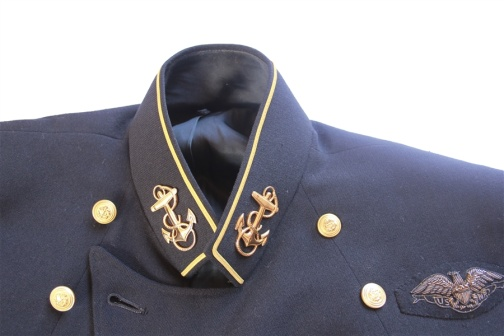Imagine this jacket was worn by a person of significant historical importance. Who could that be? Imagining this jacket was worn by a person of significant historical importance, it could belong to an esteemed naval admiral or a decorated officer responsible for leading critical maritime operations during a pivotal moment in history, such as WWII. This person could have been instrumental in orchestrating naval strategies that changed the course of wartime efforts, thus earning a uniform embellished with fine details denoting authority and high ranks. What kind of materials and craftsmanship would have been used to create such a jacket? To create such a jacket, tailors would have employed high-quality, durable materials like wool for the base fabric, ensuring it could withstand harsh conditions while providing a professional appearance. The gold accents and buttons would likely be made from gold-plated brass or similar metals, chosen for their luster and ability to hold up over time. Craftsmanship involved meticulous stitching, especially for the detailed embroidered insignias and piping. Each element would be carefully measured and placed to maintain uniformity and balance, reflecting the discipline of the wearer’s role. What kind of story can you weave around this jacket involving a fictional adventure? Picture this jacket on a daring naval officer, Captain Alexander Drake, who commanded one of the most formidable ships of the 1940s. Captain Drake was known for his sharp tactical mind and his ability to lead men through impossible odds. During one perilous mission, his ship, the HMS Vanguard, was tasked with intercepting an enemy convoy carrying crucial war supplies across treacherous waters. Against a backdrop of raging seas and encroaching enemy ships, Captain Drake's leadership and unyielding spirit led his crew to a narrow victory, capturing the convoy and turning the tide of war in favor of his nation. This jacket, now a symbol of courage and determination, was worn during that legendary battle, bearing witness to the valor and strategic genius of Captain Drake. 